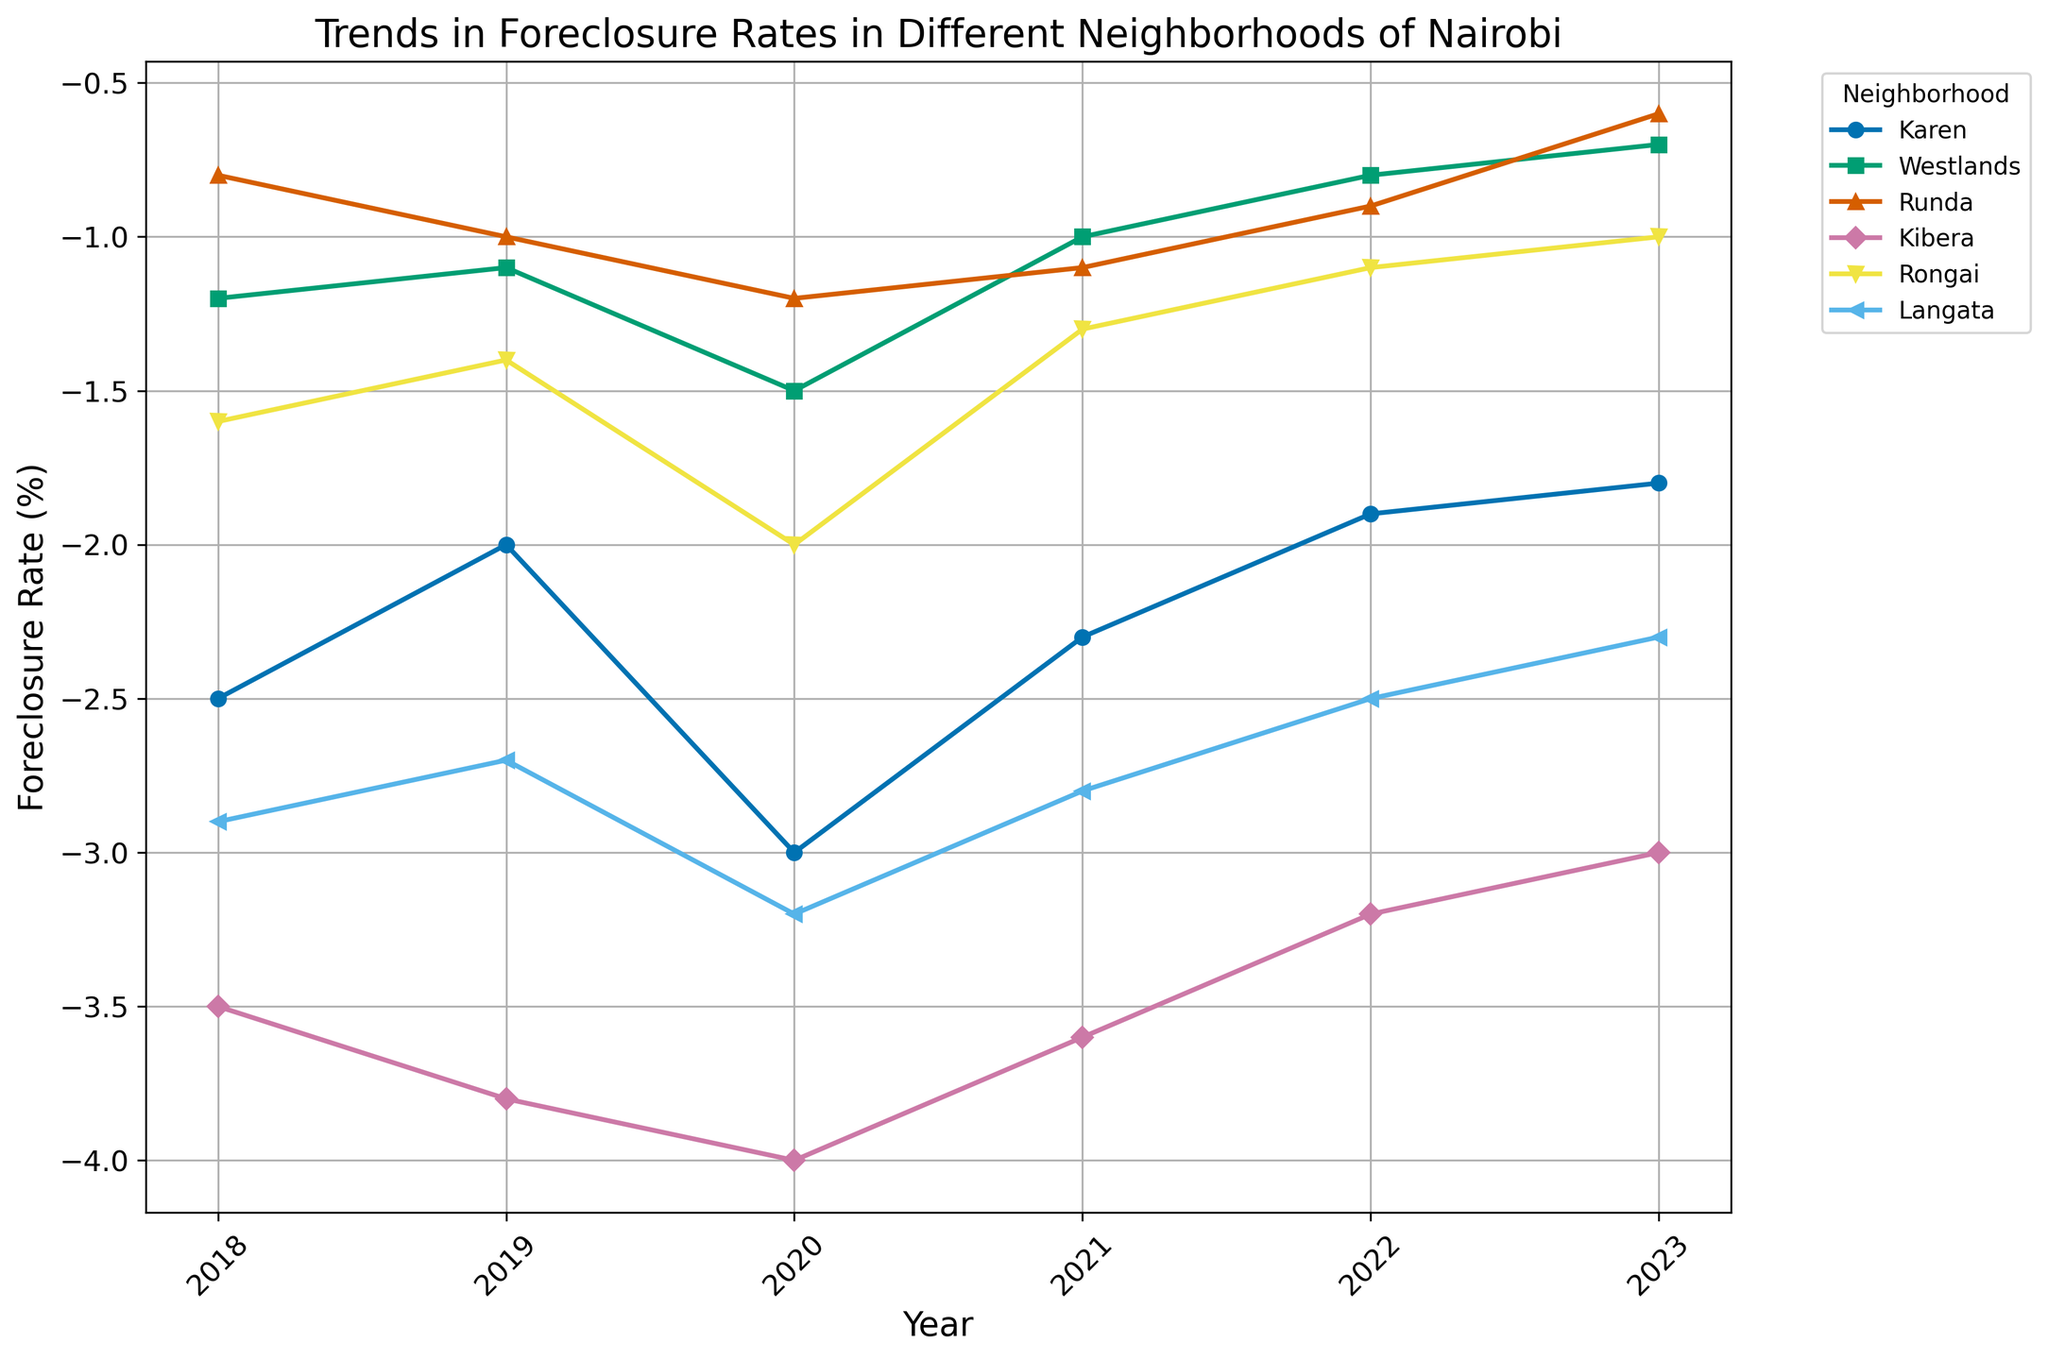Which neighborhood had the highest foreclosure rate in 2023? From the figure, identify which neighborhood corresponds to the highest y-value in 2023. Check the intersection of neighborhood lines with the year 2023 on the x-axis and find the highest negative rate on the y-axis.
Answer: Kibera Which neighborhood experienced the largest drop in foreclosure rates between 2020 and 2023? For each neighborhood, find the foreclosure rates for 2020 and 2023 from the figure, calculate the difference, and identify the neighborhood with the maximum absolute difference. Karen's rates moved from -3.0 in 2020 to -1.8 in 2023, a change of 1.2, whereas others had lesser differences.
Answer: Karen How did the foreclosure rate in Westlands change from 2018 to 2023? Find Westlands' foreclosure rates for 2018 and 2023 by locating the corresponding points on the plot and then calculate and describe the difference from 2018 to 2023.
Answer: Decreased Which two neighborhoods had the closest foreclosure rates in 2021? Identify and compare the foreclosure rates for all neighborhoods in 2021. Find the pair with the smallest difference in their foreclosure rates.
Answer: Runda and Rongai What is the general trend in foreclosure rates in Kibera from 2018 to 2023? Trace Kibera's foreclosure rates year by year from the plot. If the values generally increase, explain that the trend is upwards (more negative values indicate a larger increase).
Answer: Increase In which year did Langata have its highest foreclosure rate? Identify the data points for Langata in each year and find the point with the highest y-value (going numerically upwards from the negative values).
Answer: 2020 Compare the foreclosure rates of Runda and Rongai in 2019. Which one had the higher rate? Locate the data points for Runda and Rongai in 2019 and compare their heights. Runda is at -1.0 and Rongai at -1.4, so Runda has a less negative value, indicating a higher foreclosure rate.
Answer: Runda What is the average foreclosure rate in Karen from 2018 to 2023? Sum Karen’s foreclosure rates for each year from 2018 to 2023 and divide by the number of years (6). Calculation: (-2.5 + -2.0 + -3.0 + -2.3 + -1.9 + -1.8) / 6 = -13.5 / 6 = -2.25
Answer: -2.25 Which neighborhood showed an improvement in foreclosure rates from 2020 to 2022? Explain the improvements. Identify the foreclosure rates for each neighborhood in 2020 and 2022. Compare the two values and check the neighborhoods where the rate decreased (became less negative).
Answer: All neighborhoods showed improvement except Kibera What was the foreclosure rate in Langata in 2020? Identify the Langata data point for 2020 on the plot and read the corresponding y-value.
Answer: -3.2 